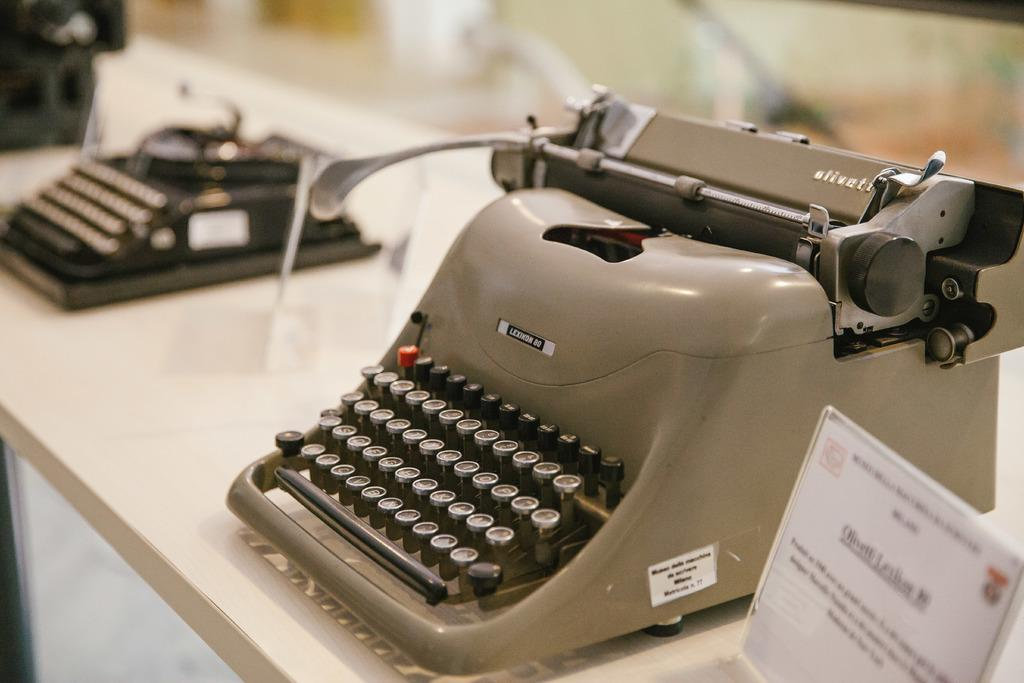<image>
Render a clear and concise summary of the photo. An old fashioned manual typewriter that says Lexington on it. 